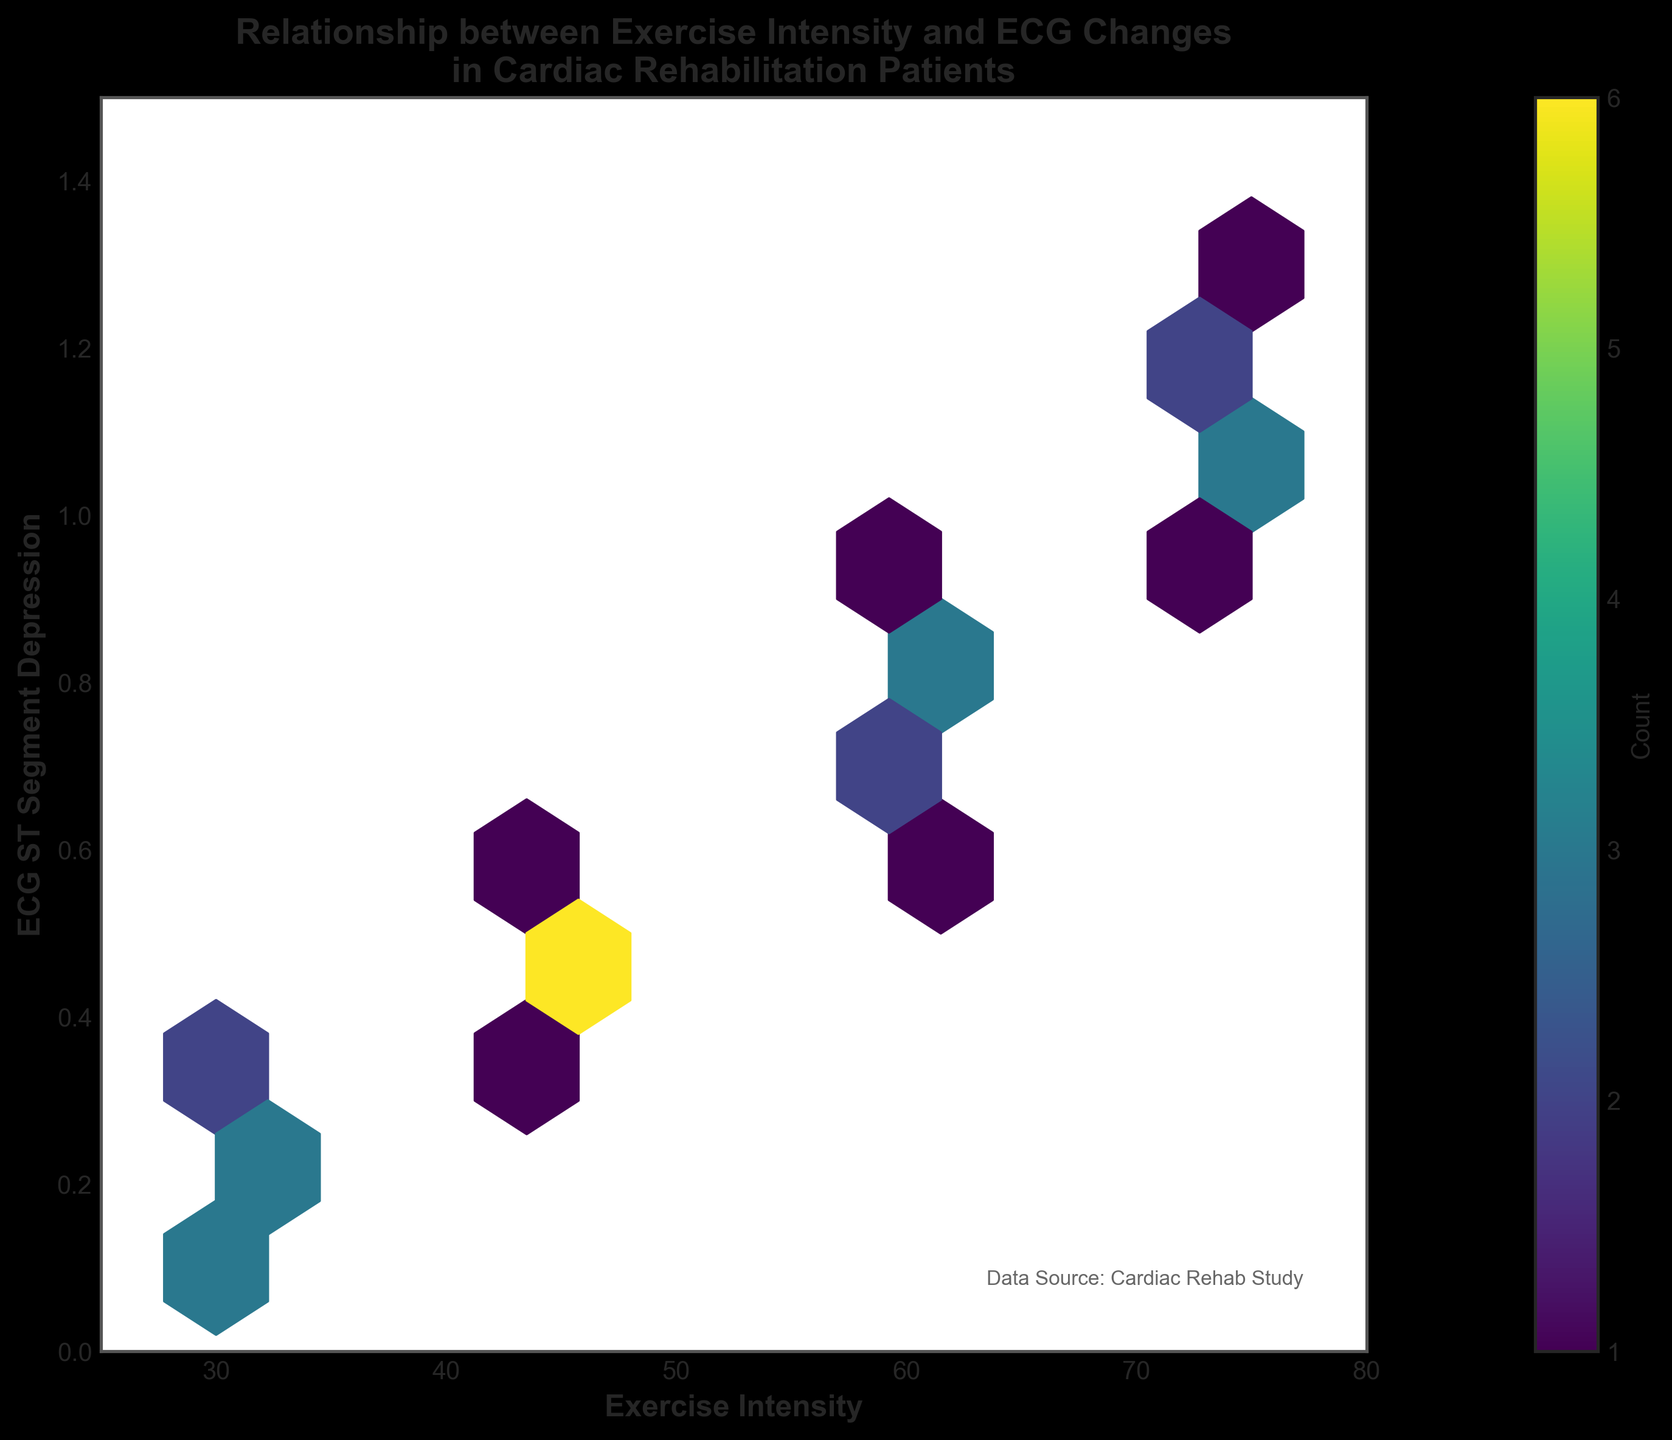What does the title of the hexbin plot indicate? The title of the hexbin plot provides a brief description of the main focus of the data visualization. It indicates that the plot shows the relationship between exercise intensity and changes in ECG patterns specifically for cardiac rehabilitation patients.
Answer: Relationship between Exercise Intensity and ECG Changes in Cardiac Rehabilitation Patients What are the ranges for the x-axis and y-axis? The ranges for the x-axis and y-axis are indicated by the tick marks and labels at the bottom and the side of the plot. The x-axis, representing Exercise Intensity, ranges from 25 to 80, and the y-axis, representing ECG ST Segment Depression, ranges from 0 to 1.5.
Answer: x-axis: 25-80, y-axis: 0-1.5 Which part of the plot represents the maximum data density? The areas with the highest data density are visually represented by the regions with the darkest color in the hexbin plot. In this plot, the maximum data density is observed in the regions where count is highest, typically represented by darker color near specific exercise intensities and ECG values.
Answer: The darkest regions of the plot How does the color scale on the hexbin plot function? The color scale on the hexbin plot represents the density of data points in each hexagon. The color bar on the plot shows that lighter colors represent fewer data points in that hexbin, while darker colors represent higher counts of data points.
Answer: Darker color indicates higher density What do the labels on the color bar represent? The labels on the color bar represent the counts of data points within each hexagon. The color bar indicates that the color gradient from light to dark corresponds to increasing counts of data points in the hexagons on the plot.
Answer: Data point counts What can be inferred about patients with a high exercise intensity based on the plot? By examining the plot, we can infer that patients with higher exercise intensity (near 75) tend to have higher values of ECG ST Segment Depression. This is indicated by the clustering of data points in darker hexagons at higher exercise intensities and higher depression values.
Answer: Higher exercise intensity correlates with higher ECG ST Segment Depression Is there a clear linear relationship between exercise intensity and ECG ST Segment Depression? The hexbin plot reveals that there is a general trend where higher exercise intensity values are associated with higher ECG ST Segment Depression, but the relationship is not perfectly linear. Some scatter and variability are present, indicating other factors might be influencing the ECG ST Segment Depression.
Answer: No clear linear relationship, but a general positive trend Between which exercise intensity values is the transition in ECG ST Segment Depression most noticeable? Observing the hexbin plot, the transition in ECG ST Segment Depression values appears to be most noticeable between exercise intensities of 45 and 60, as evidenced by a change in density clustering and color transition in those regions.
Answer: Between 45 and 60 